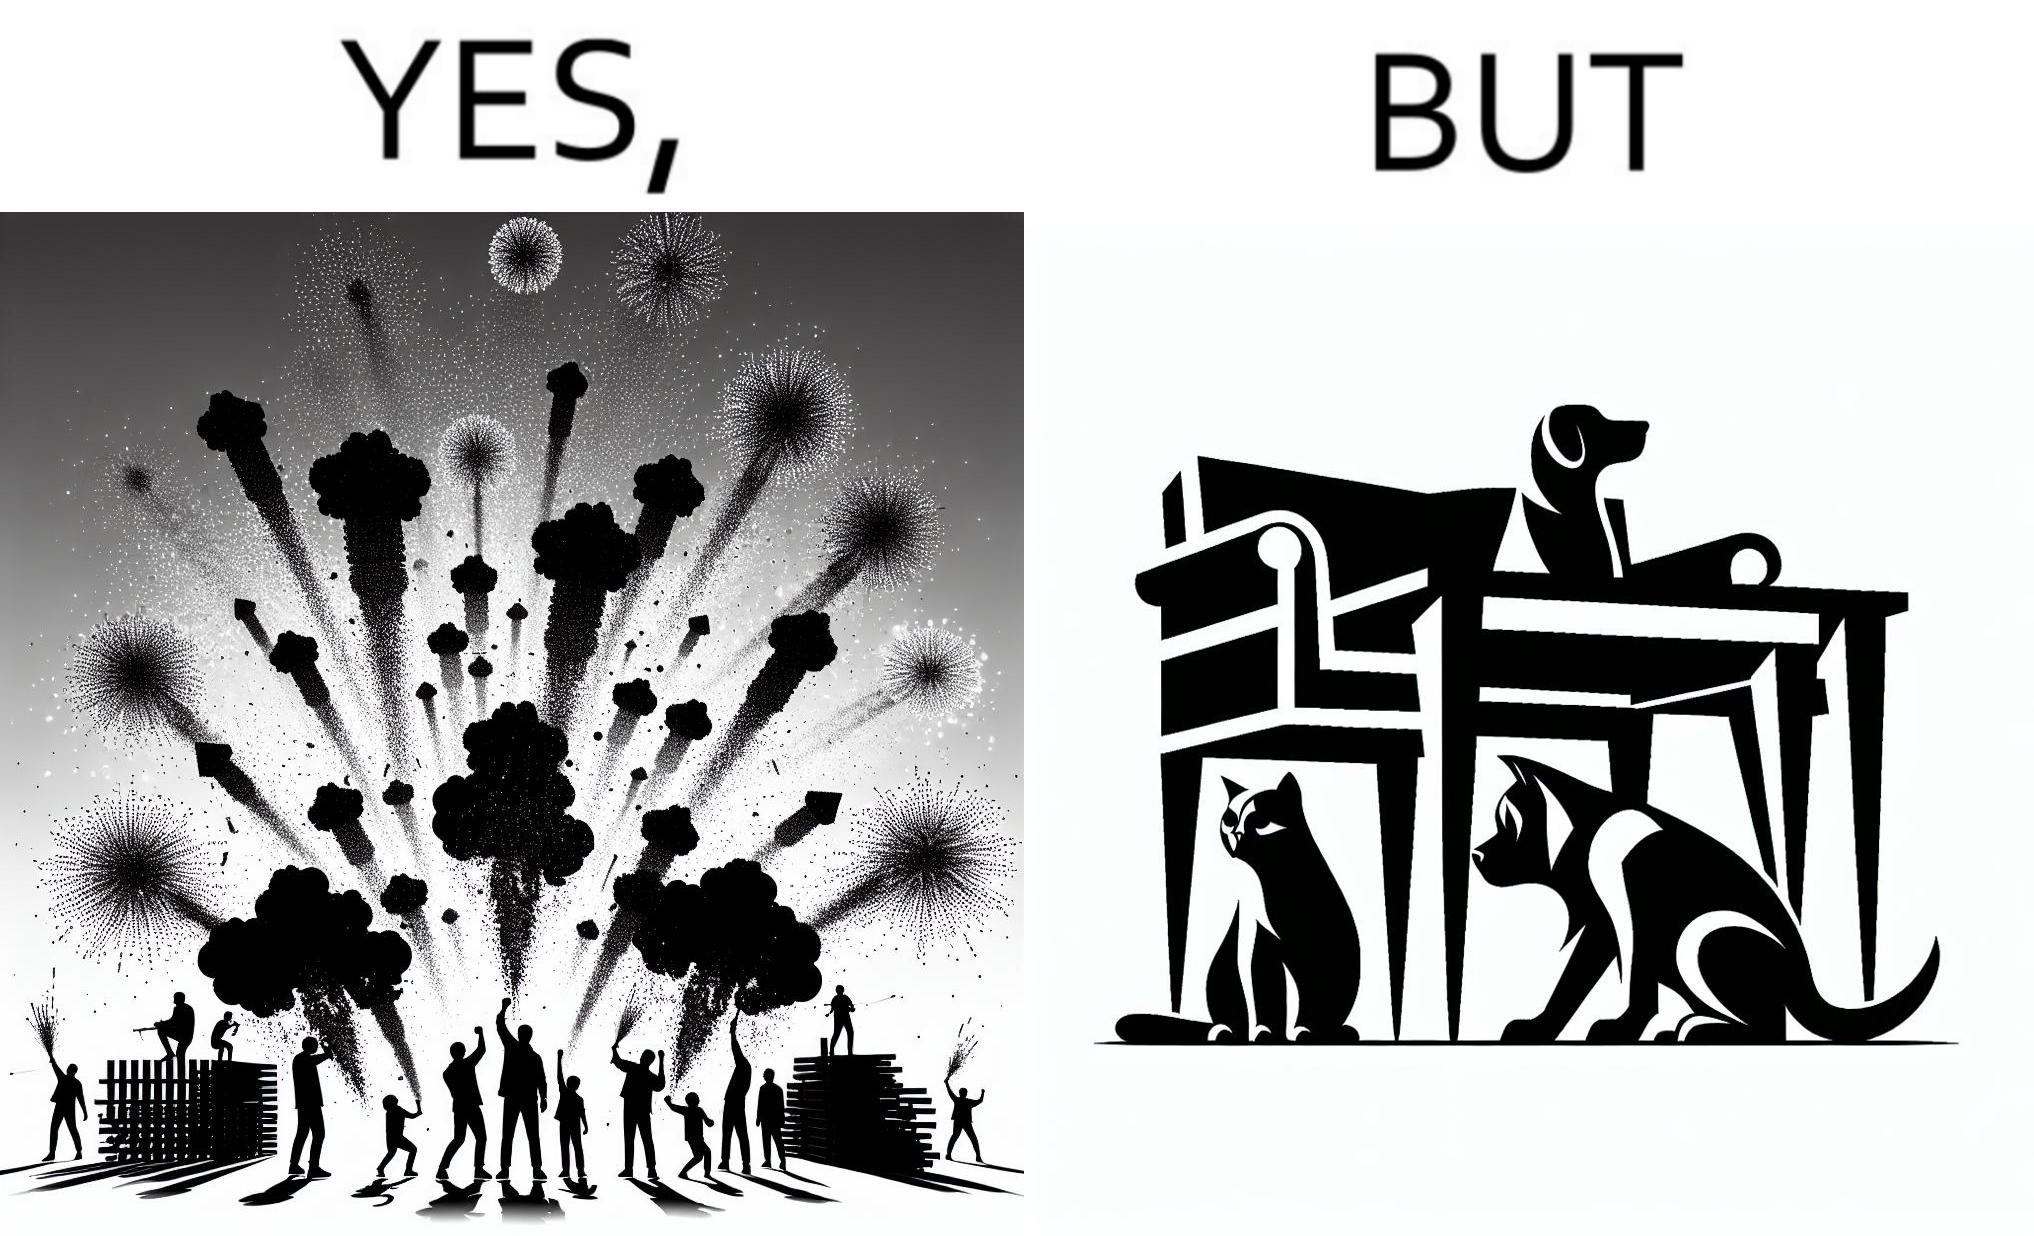Explain why this image is satirical. The image is satirical because while firecrackers in the sky look pretty, not everyone likes them. Animals are very scared of the firecrackers. 